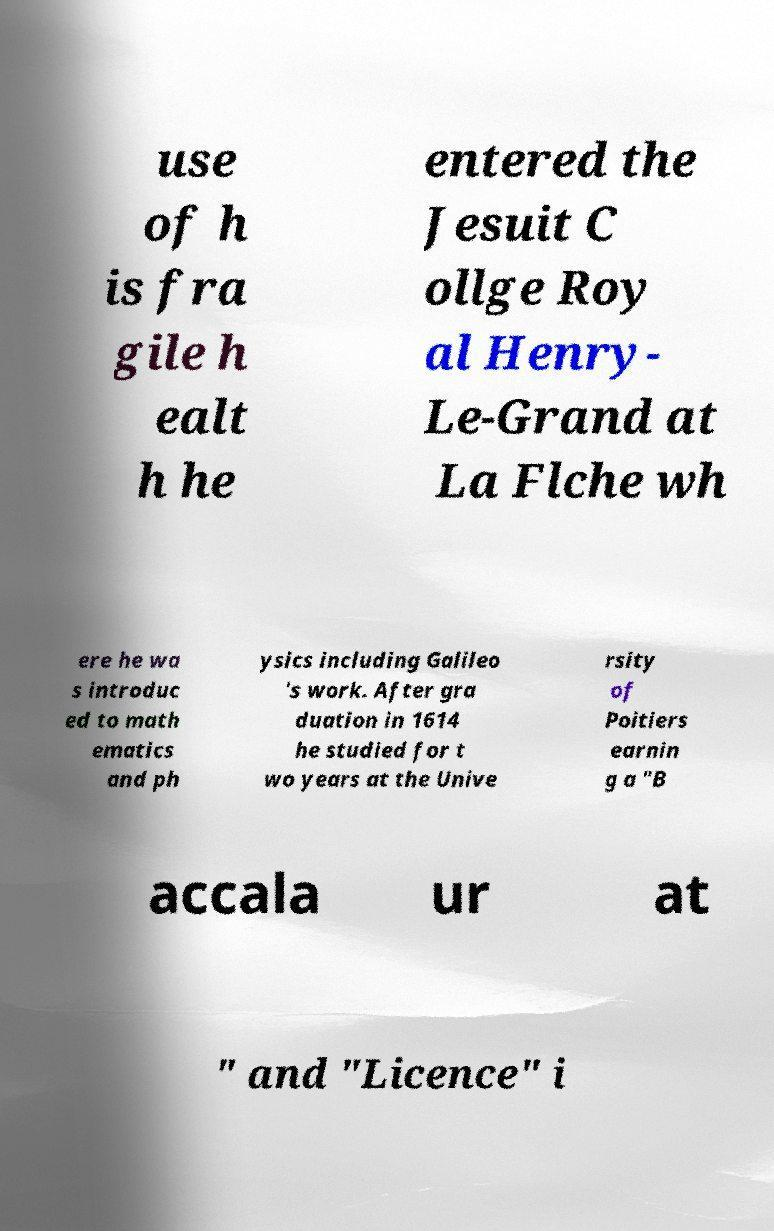What messages or text are displayed in this image? I need them in a readable, typed format. use of h is fra gile h ealt h he entered the Jesuit C ollge Roy al Henry- Le-Grand at La Flche wh ere he wa s introduc ed to math ematics and ph ysics including Galileo 's work. After gra duation in 1614 he studied for t wo years at the Unive rsity of Poitiers earnin g a "B accala ur at " and "Licence" i 